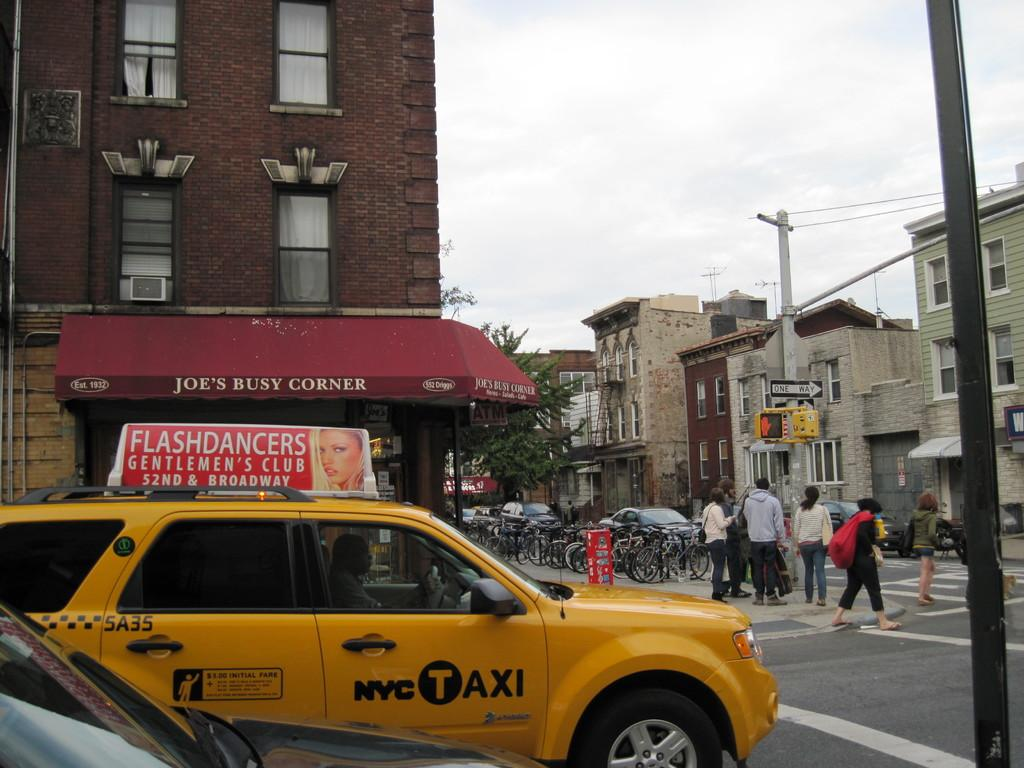<image>
Offer a succinct explanation of the picture presented. a car that has the word taxi on it 